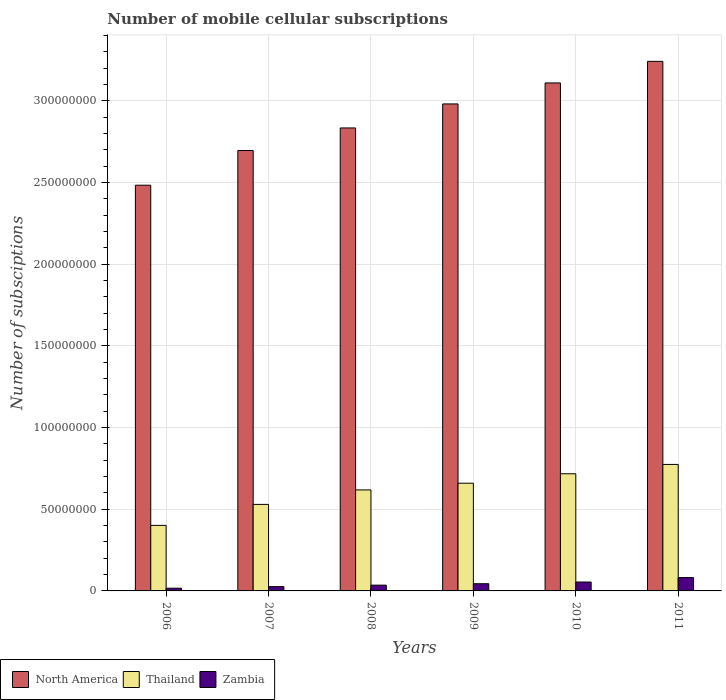How many different coloured bars are there?
Your response must be concise. 3. Are the number of bars per tick equal to the number of legend labels?
Your response must be concise. Yes. What is the number of mobile cellular subscriptions in North America in 2011?
Your answer should be very brief. 3.24e+08. Across all years, what is the maximum number of mobile cellular subscriptions in North America?
Ensure brevity in your answer.  3.24e+08. Across all years, what is the minimum number of mobile cellular subscriptions in Zambia?
Keep it short and to the point. 1.66e+06. In which year was the number of mobile cellular subscriptions in Thailand maximum?
Offer a terse response. 2011. What is the total number of mobile cellular subscriptions in Zambia in the graph?
Provide a short and direct response. 2.59e+07. What is the difference between the number of mobile cellular subscriptions in Zambia in 2008 and that in 2011?
Your response must be concise. -4.63e+06. What is the difference between the number of mobile cellular subscriptions in Thailand in 2011 and the number of mobile cellular subscriptions in North America in 2009?
Provide a short and direct response. -2.21e+08. What is the average number of mobile cellular subscriptions in North America per year?
Keep it short and to the point. 2.89e+08. In the year 2007, what is the difference between the number of mobile cellular subscriptions in North America and number of mobile cellular subscriptions in Zambia?
Offer a terse response. 2.67e+08. In how many years, is the number of mobile cellular subscriptions in North America greater than 320000000?
Offer a very short reply. 1. What is the ratio of the number of mobile cellular subscriptions in North America in 2009 to that in 2011?
Your answer should be very brief. 0.92. What is the difference between the highest and the second highest number of mobile cellular subscriptions in Zambia?
Offer a very short reply. 2.72e+06. What is the difference between the highest and the lowest number of mobile cellular subscriptions in North America?
Keep it short and to the point. 7.58e+07. In how many years, is the number of mobile cellular subscriptions in Thailand greater than the average number of mobile cellular subscriptions in Thailand taken over all years?
Offer a terse response. 4. What does the 3rd bar from the left in 2008 represents?
Ensure brevity in your answer.  Zambia. What does the 3rd bar from the right in 2011 represents?
Provide a short and direct response. North America. How many bars are there?
Your response must be concise. 18. Are all the bars in the graph horizontal?
Give a very brief answer. No. Are the values on the major ticks of Y-axis written in scientific E-notation?
Give a very brief answer. No. Does the graph contain any zero values?
Provide a succinct answer. No. Does the graph contain grids?
Make the answer very short. Yes. How are the legend labels stacked?
Provide a short and direct response. Horizontal. What is the title of the graph?
Your response must be concise. Number of mobile cellular subscriptions. What is the label or title of the X-axis?
Ensure brevity in your answer.  Years. What is the label or title of the Y-axis?
Give a very brief answer. Number of subsciptions. What is the Number of subsciptions in North America in 2006?
Offer a terse response. 2.48e+08. What is the Number of subsciptions in Thailand in 2006?
Provide a short and direct response. 4.01e+07. What is the Number of subsciptions of Zambia in 2006?
Your answer should be very brief. 1.66e+06. What is the Number of subsciptions in North America in 2007?
Give a very brief answer. 2.70e+08. What is the Number of subsciptions in Thailand in 2007?
Offer a very short reply. 5.30e+07. What is the Number of subsciptions of Zambia in 2007?
Make the answer very short. 2.64e+06. What is the Number of subsciptions of North America in 2008?
Offer a very short reply. 2.83e+08. What is the Number of subsciptions of Thailand in 2008?
Ensure brevity in your answer.  6.18e+07. What is the Number of subsciptions in Zambia in 2008?
Keep it short and to the point. 3.54e+06. What is the Number of subsciptions of North America in 2009?
Offer a very short reply. 2.98e+08. What is the Number of subsciptions in Thailand in 2009?
Provide a short and direct response. 6.60e+07. What is the Number of subsciptions of Zambia in 2009?
Offer a terse response. 4.41e+06. What is the Number of subsciptions in North America in 2010?
Give a very brief answer. 3.11e+08. What is the Number of subsciptions in Thailand in 2010?
Offer a very short reply. 7.17e+07. What is the Number of subsciptions in Zambia in 2010?
Ensure brevity in your answer.  5.45e+06. What is the Number of subsciptions of North America in 2011?
Your response must be concise. 3.24e+08. What is the Number of subsciptions in Thailand in 2011?
Offer a very short reply. 7.74e+07. What is the Number of subsciptions in Zambia in 2011?
Provide a succinct answer. 8.16e+06. Across all years, what is the maximum Number of subsciptions of North America?
Give a very brief answer. 3.24e+08. Across all years, what is the maximum Number of subsciptions in Thailand?
Your answer should be very brief. 7.74e+07. Across all years, what is the maximum Number of subsciptions in Zambia?
Keep it short and to the point. 8.16e+06. Across all years, what is the minimum Number of subsciptions in North America?
Your response must be concise. 2.48e+08. Across all years, what is the minimum Number of subsciptions in Thailand?
Your answer should be compact. 4.01e+07. Across all years, what is the minimum Number of subsciptions of Zambia?
Provide a succinct answer. 1.66e+06. What is the total Number of subsciptions in North America in the graph?
Make the answer very short. 1.73e+09. What is the total Number of subsciptions in Thailand in the graph?
Your response must be concise. 3.70e+08. What is the total Number of subsciptions in Zambia in the graph?
Provide a short and direct response. 2.59e+07. What is the difference between the Number of subsciptions of North America in 2006 and that in 2007?
Provide a succinct answer. -2.12e+07. What is the difference between the Number of subsciptions in Thailand in 2006 and that in 2007?
Ensure brevity in your answer.  -1.28e+07. What is the difference between the Number of subsciptions in Zambia in 2006 and that in 2007?
Provide a short and direct response. -9.76e+05. What is the difference between the Number of subsciptions of North America in 2006 and that in 2008?
Offer a terse response. -3.51e+07. What is the difference between the Number of subsciptions of Thailand in 2006 and that in 2008?
Your answer should be very brief. -2.17e+07. What is the difference between the Number of subsciptions in Zambia in 2006 and that in 2008?
Provide a succinct answer. -1.88e+06. What is the difference between the Number of subsciptions in North America in 2006 and that in 2009?
Make the answer very short. -4.98e+07. What is the difference between the Number of subsciptions of Thailand in 2006 and that in 2009?
Give a very brief answer. -2.58e+07. What is the difference between the Number of subsciptions in Zambia in 2006 and that in 2009?
Your answer should be compact. -2.74e+06. What is the difference between the Number of subsciptions in North America in 2006 and that in 2010?
Keep it short and to the point. -6.26e+07. What is the difference between the Number of subsciptions of Thailand in 2006 and that in 2010?
Give a very brief answer. -3.16e+07. What is the difference between the Number of subsciptions in Zambia in 2006 and that in 2010?
Your response must be concise. -3.78e+06. What is the difference between the Number of subsciptions in North America in 2006 and that in 2011?
Provide a short and direct response. -7.58e+07. What is the difference between the Number of subsciptions in Thailand in 2006 and that in 2011?
Your answer should be very brief. -3.73e+07. What is the difference between the Number of subsciptions of Zambia in 2006 and that in 2011?
Provide a succinct answer. -6.50e+06. What is the difference between the Number of subsciptions in North America in 2007 and that in 2008?
Your answer should be compact. -1.38e+07. What is the difference between the Number of subsciptions of Thailand in 2007 and that in 2008?
Offer a very short reply. -8.86e+06. What is the difference between the Number of subsciptions in Zambia in 2007 and that in 2008?
Make the answer very short. -9.00e+05. What is the difference between the Number of subsciptions in North America in 2007 and that in 2009?
Offer a very short reply. -2.85e+07. What is the difference between the Number of subsciptions of Thailand in 2007 and that in 2009?
Provide a succinct answer. -1.30e+07. What is the difference between the Number of subsciptions in Zambia in 2007 and that in 2009?
Provide a short and direct response. -1.77e+06. What is the difference between the Number of subsciptions in North America in 2007 and that in 2010?
Your response must be concise. -4.14e+07. What is the difference between the Number of subsciptions in Thailand in 2007 and that in 2010?
Give a very brief answer. -1.88e+07. What is the difference between the Number of subsciptions of Zambia in 2007 and that in 2010?
Provide a succinct answer. -2.81e+06. What is the difference between the Number of subsciptions in North America in 2007 and that in 2011?
Your answer should be very brief. -5.46e+07. What is the difference between the Number of subsciptions in Thailand in 2007 and that in 2011?
Keep it short and to the point. -2.45e+07. What is the difference between the Number of subsciptions of Zambia in 2007 and that in 2011?
Offer a very short reply. -5.53e+06. What is the difference between the Number of subsciptions in North America in 2008 and that in 2009?
Ensure brevity in your answer.  -1.47e+07. What is the difference between the Number of subsciptions of Thailand in 2008 and that in 2009?
Give a very brief answer. -4.12e+06. What is the difference between the Number of subsciptions in Zambia in 2008 and that in 2009?
Your answer should be very brief. -8.68e+05. What is the difference between the Number of subsciptions in North America in 2008 and that in 2010?
Keep it short and to the point. -2.76e+07. What is the difference between the Number of subsciptions in Thailand in 2008 and that in 2010?
Ensure brevity in your answer.  -9.89e+06. What is the difference between the Number of subsciptions in Zambia in 2008 and that in 2010?
Your response must be concise. -1.91e+06. What is the difference between the Number of subsciptions in North America in 2008 and that in 2011?
Offer a very short reply. -4.08e+07. What is the difference between the Number of subsciptions in Thailand in 2008 and that in 2011?
Give a very brief answer. -1.56e+07. What is the difference between the Number of subsciptions of Zambia in 2008 and that in 2011?
Your response must be concise. -4.63e+06. What is the difference between the Number of subsciptions of North America in 2009 and that in 2010?
Make the answer very short. -1.29e+07. What is the difference between the Number of subsciptions in Thailand in 2009 and that in 2010?
Provide a short and direct response. -5.77e+06. What is the difference between the Number of subsciptions of Zambia in 2009 and that in 2010?
Your answer should be very brief. -1.04e+06. What is the difference between the Number of subsciptions of North America in 2009 and that in 2011?
Make the answer very short. -2.61e+07. What is the difference between the Number of subsciptions of Thailand in 2009 and that in 2011?
Give a very brief answer. -1.15e+07. What is the difference between the Number of subsciptions in Zambia in 2009 and that in 2011?
Provide a succinct answer. -3.76e+06. What is the difference between the Number of subsciptions of North America in 2010 and that in 2011?
Your answer should be compact. -1.32e+07. What is the difference between the Number of subsciptions of Thailand in 2010 and that in 2011?
Your answer should be compact. -5.72e+06. What is the difference between the Number of subsciptions in Zambia in 2010 and that in 2011?
Your response must be concise. -2.72e+06. What is the difference between the Number of subsciptions in North America in 2006 and the Number of subsciptions in Thailand in 2007?
Keep it short and to the point. 1.95e+08. What is the difference between the Number of subsciptions of North America in 2006 and the Number of subsciptions of Zambia in 2007?
Keep it short and to the point. 2.46e+08. What is the difference between the Number of subsciptions of Thailand in 2006 and the Number of subsciptions of Zambia in 2007?
Your answer should be very brief. 3.75e+07. What is the difference between the Number of subsciptions of North America in 2006 and the Number of subsciptions of Thailand in 2008?
Your answer should be compact. 1.87e+08. What is the difference between the Number of subsciptions of North America in 2006 and the Number of subsciptions of Zambia in 2008?
Give a very brief answer. 2.45e+08. What is the difference between the Number of subsciptions in Thailand in 2006 and the Number of subsciptions in Zambia in 2008?
Provide a succinct answer. 3.66e+07. What is the difference between the Number of subsciptions in North America in 2006 and the Number of subsciptions in Thailand in 2009?
Your answer should be compact. 1.82e+08. What is the difference between the Number of subsciptions in North America in 2006 and the Number of subsciptions in Zambia in 2009?
Provide a short and direct response. 2.44e+08. What is the difference between the Number of subsciptions in Thailand in 2006 and the Number of subsciptions in Zambia in 2009?
Offer a very short reply. 3.57e+07. What is the difference between the Number of subsciptions of North America in 2006 and the Number of subsciptions of Thailand in 2010?
Offer a terse response. 1.77e+08. What is the difference between the Number of subsciptions of North America in 2006 and the Number of subsciptions of Zambia in 2010?
Offer a terse response. 2.43e+08. What is the difference between the Number of subsciptions of Thailand in 2006 and the Number of subsciptions of Zambia in 2010?
Make the answer very short. 3.47e+07. What is the difference between the Number of subsciptions in North America in 2006 and the Number of subsciptions in Thailand in 2011?
Your answer should be compact. 1.71e+08. What is the difference between the Number of subsciptions of North America in 2006 and the Number of subsciptions of Zambia in 2011?
Keep it short and to the point. 2.40e+08. What is the difference between the Number of subsciptions in Thailand in 2006 and the Number of subsciptions in Zambia in 2011?
Make the answer very short. 3.20e+07. What is the difference between the Number of subsciptions in North America in 2007 and the Number of subsciptions in Thailand in 2008?
Offer a very short reply. 2.08e+08. What is the difference between the Number of subsciptions of North America in 2007 and the Number of subsciptions of Zambia in 2008?
Give a very brief answer. 2.66e+08. What is the difference between the Number of subsciptions in Thailand in 2007 and the Number of subsciptions in Zambia in 2008?
Offer a very short reply. 4.94e+07. What is the difference between the Number of subsciptions in North America in 2007 and the Number of subsciptions in Thailand in 2009?
Your answer should be compact. 2.04e+08. What is the difference between the Number of subsciptions in North America in 2007 and the Number of subsciptions in Zambia in 2009?
Provide a short and direct response. 2.65e+08. What is the difference between the Number of subsciptions of Thailand in 2007 and the Number of subsciptions of Zambia in 2009?
Your response must be concise. 4.86e+07. What is the difference between the Number of subsciptions of North America in 2007 and the Number of subsciptions of Thailand in 2010?
Your response must be concise. 1.98e+08. What is the difference between the Number of subsciptions in North America in 2007 and the Number of subsciptions in Zambia in 2010?
Offer a very short reply. 2.64e+08. What is the difference between the Number of subsciptions of Thailand in 2007 and the Number of subsciptions of Zambia in 2010?
Make the answer very short. 4.75e+07. What is the difference between the Number of subsciptions of North America in 2007 and the Number of subsciptions of Thailand in 2011?
Make the answer very short. 1.92e+08. What is the difference between the Number of subsciptions in North America in 2007 and the Number of subsciptions in Zambia in 2011?
Offer a terse response. 2.61e+08. What is the difference between the Number of subsciptions of Thailand in 2007 and the Number of subsciptions of Zambia in 2011?
Your response must be concise. 4.48e+07. What is the difference between the Number of subsciptions of North America in 2008 and the Number of subsciptions of Thailand in 2009?
Offer a terse response. 2.18e+08. What is the difference between the Number of subsciptions of North America in 2008 and the Number of subsciptions of Zambia in 2009?
Your response must be concise. 2.79e+08. What is the difference between the Number of subsciptions of Thailand in 2008 and the Number of subsciptions of Zambia in 2009?
Give a very brief answer. 5.74e+07. What is the difference between the Number of subsciptions in North America in 2008 and the Number of subsciptions in Thailand in 2010?
Make the answer very short. 2.12e+08. What is the difference between the Number of subsciptions of North America in 2008 and the Number of subsciptions of Zambia in 2010?
Provide a short and direct response. 2.78e+08. What is the difference between the Number of subsciptions in Thailand in 2008 and the Number of subsciptions in Zambia in 2010?
Ensure brevity in your answer.  5.64e+07. What is the difference between the Number of subsciptions in North America in 2008 and the Number of subsciptions in Thailand in 2011?
Make the answer very short. 2.06e+08. What is the difference between the Number of subsciptions in North America in 2008 and the Number of subsciptions in Zambia in 2011?
Your answer should be compact. 2.75e+08. What is the difference between the Number of subsciptions of Thailand in 2008 and the Number of subsciptions of Zambia in 2011?
Provide a short and direct response. 5.37e+07. What is the difference between the Number of subsciptions of North America in 2009 and the Number of subsciptions of Thailand in 2010?
Give a very brief answer. 2.26e+08. What is the difference between the Number of subsciptions of North America in 2009 and the Number of subsciptions of Zambia in 2010?
Ensure brevity in your answer.  2.93e+08. What is the difference between the Number of subsciptions of Thailand in 2009 and the Number of subsciptions of Zambia in 2010?
Give a very brief answer. 6.05e+07. What is the difference between the Number of subsciptions of North America in 2009 and the Number of subsciptions of Thailand in 2011?
Give a very brief answer. 2.21e+08. What is the difference between the Number of subsciptions in North America in 2009 and the Number of subsciptions in Zambia in 2011?
Keep it short and to the point. 2.90e+08. What is the difference between the Number of subsciptions of Thailand in 2009 and the Number of subsciptions of Zambia in 2011?
Offer a very short reply. 5.78e+07. What is the difference between the Number of subsciptions of North America in 2010 and the Number of subsciptions of Thailand in 2011?
Offer a very short reply. 2.34e+08. What is the difference between the Number of subsciptions of North America in 2010 and the Number of subsciptions of Zambia in 2011?
Your answer should be very brief. 3.03e+08. What is the difference between the Number of subsciptions of Thailand in 2010 and the Number of subsciptions of Zambia in 2011?
Keep it short and to the point. 6.36e+07. What is the average Number of subsciptions of North America per year?
Offer a terse response. 2.89e+08. What is the average Number of subsciptions in Thailand per year?
Your response must be concise. 6.17e+07. What is the average Number of subsciptions in Zambia per year?
Your answer should be compact. 4.31e+06. In the year 2006, what is the difference between the Number of subsciptions in North America and Number of subsciptions in Thailand?
Offer a very short reply. 2.08e+08. In the year 2006, what is the difference between the Number of subsciptions of North America and Number of subsciptions of Zambia?
Keep it short and to the point. 2.47e+08. In the year 2006, what is the difference between the Number of subsciptions of Thailand and Number of subsciptions of Zambia?
Your answer should be compact. 3.85e+07. In the year 2007, what is the difference between the Number of subsciptions of North America and Number of subsciptions of Thailand?
Your response must be concise. 2.17e+08. In the year 2007, what is the difference between the Number of subsciptions of North America and Number of subsciptions of Zambia?
Provide a short and direct response. 2.67e+08. In the year 2007, what is the difference between the Number of subsciptions in Thailand and Number of subsciptions in Zambia?
Give a very brief answer. 5.03e+07. In the year 2008, what is the difference between the Number of subsciptions in North America and Number of subsciptions in Thailand?
Offer a terse response. 2.22e+08. In the year 2008, what is the difference between the Number of subsciptions in North America and Number of subsciptions in Zambia?
Provide a short and direct response. 2.80e+08. In the year 2008, what is the difference between the Number of subsciptions in Thailand and Number of subsciptions in Zambia?
Provide a succinct answer. 5.83e+07. In the year 2009, what is the difference between the Number of subsciptions of North America and Number of subsciptions of Thailand?
Offer a very short reply. 2.32e+08. In the year 2009, what is the difference between the Number of subsciptions in North America and Number of subsciptions in Zambia?
Your answer should be very brief. 2.94e+08. In the year 2009, what is the difference between the Number of subsciptions of Thailand and Number of subsciptions of Zambia?
Your answer should be very brief. 6.15e+07. In the year 2010, what is the difference between the Number of subsciptions in North America and Number of subsciptions in Thailand?
Give a very brief answer. 2.39e+08. In the year 2010, what is the difference between the Number of subsciptions of North America and Number of subsciptions of Zambia?
Offer a terse response. 3.06e+08. In the year 2010, what is the difference between the Number of subsciptions of Thailand and Number of subsciptions of Zambia?
Your response must be concise. 6.63e+07. In the year 2011, what is the difference between the Number of subsciptions in North America and Number of subsciptions in Thailand?
Offer a very short reply. 2.47e+08. In the year 2011, what is the difference between the Number of subsciptions of North America and Number of subsciptions of Zambia?
Offer a terse response. 3.16e+08. In the year 2011, what is the difference between the Number of subsciptions of Thailand and Number of subsciptions of Zambia?
Make the answer very short. 6.93e+07. What is the ratio of the Number of subsciptions of North America in 2006 to that in 2007?
Provide a short and direct response. 0.92. What is the ratio of the Number of subsciptions in Thailand in 2006 to that in 2007?
Your response must be concise. 0.76. What is the ratio of the Number of subsciptions of Zambia in 2006 to that in 2007?
Provide a succinct answer. 0.63. What is the ratio of the Number of subsciptions in North America in 2006 to that in 2008?
Your answer should be compact. 0.88. What is the ratio of the Number of subsciptions in Thailand in 2006 to that in 2008?
Ensure brevity in your answer.  0.65. What is the ratio of the Number of subsciptions of Zambia in 2006 to that in 2008?
Make the answer very short. 0.47. What is the ratio of the Number of subsciptions of North America in 2006 to that in 2009?
Keep it short and to the point. 0.83. What is the ratio of the Number of subsciptions in Thailand in 2006 to that in 2009?
Ensure brevity in your answer.  0.61. What is the ratio of the Number of subsciptions in Zambia in 2006 to that in 2009?
Ensure brevity in your answer.  0.38. What is the ratio of the Number of subsciptions in North America in 2006 to that in 2010?
Your response must be concise. 0.8. What is the ratio of the Number of subsciptions of Thailand in 2006 to that in 2010?
Give a very brief answer. 0.56. What is the ratio of the Number of subsciptions of Zambia in 2006 to that in 2010?
Keep it short and to the point. 0.31. What is the ratio of the Number of subsciptions of North America in 2006 to that in 2011?
Ensure brevity in your answer.  0.77. What is the ratio of the Number of subsciptions in Thailand in 2006 to that in 2011?
Provide a short and direct response. 0.52. What is the ratio of the Number of subsciptions of Zambia in 2006 to that in 2011?
Offer a very short reply. 0.2. What is the ratio of the Number of subsciptions of North America in 2007 to that in 2008?
Provide a short and direct response. 0.95. What is the ratio of the Number of subsciptions of Thailand in 2007 to that in 2008?
Your answer should be compact. 0.86. What is the ratio of the Number of subsciptions of Zambia in 2007 to that in 2008?
Offer a terse response. 0.75. What is the ratio of the Number of subsciptions in North America in 2007 to that in 2009?
Your response must be concise. 0.9. What is the ratio of the Number of subsciptions in Thailand in 2007 to that in 2009?
Make the answer very short. 0.8. What is the ratio of the Number of subsciptions of Zambia in 2007 to that in 2009?
Keep it short and to the point. 0.6. What is the ratio of the Number of subsciptions of North America in 2007 to that in 2010?
Give a very brief answer. 0.87. What is the ratio of the Number of subsciptions in Thailand in 2007 to that in 2010?
Provide a succinct answer. 0.74. What is the ratio of the Number of subsciptions in Zambia in 2007 to that in 2010?
Give a very brief answer. 0.48. What is the ratio of the Number of subsciptions in North America in 2007 to that in 2011?
Ensure brevity in your answer.  0.83. What is the ratio of the Number of subsciptions of Thailand in 2007 to that in 2011?
Your response must be concise. 0.68. What is the ratio of the Number of subsciptions in Zambia in 2007 to that in 2011?
Provide a short and direct response. 0.32. What is the ratio of the Number of subsciptions of North America in 2008 to that in 2009?
Provide a short and direct response. 0.95. What is the ratio of the Number of subsciptions in Thailand in 2008 to that in 2009?
Make the answer very short. 0.94. What is the ratio of the Number of subsciptions of Zambia in 2008 to that in 2009?
Give a very brief answer. 0.8. What is the ratio of the Number of subsciptions in North America in 2008 to that in 2010?
Your answer should be very brief. 0.91. What is the ratio of the Number of subsciptions of Thailand in 2008 to that in 2010?
Make the answer very short. 0.86. What is the ratio of the Number of subsciptions of Zambia in 2008 to that in 2010?
Ensure brevity in your answer.  0.65. What is the ratio of the Number of subsciptions of North America in 2008 to that in 2011?
Ensure brevity in your answer.  0.87. What is the ratio of the Number of subsciptions in Thailand in 2008 to that in 2011?
Keep it short and to the point. 0.8. What is the ratio of the Number of subsciptions of Zambia in 2008 to that in 2011?
Ensure brevity in your answer.  0.43. What is the ratio of the Number of subsciptions in North America in 2009 to that in 2010?
Provide a short and direct response. 0.96. What is the ratio of the Number of subsciptions in Thailand in 2009 to that in 2010?
Your response must be concise. 0.92. What is the ratio of the Number of subsciptions in Zambia in 2009 to that in 2010?
Ensure brevity in your answer.  0.81. What is the ratio of the Number of subsciptions of North America in 2009 to that in 2011?
Your answer should be very brief. 0.92. What is the ratio of the Number of subsciptions of Thailand in 2009 to that in 2011?
Your response must be concise. 0.85. What is the ratio of the Number of subsciptions of Zambia in 2009 to that in 2011?
Keep it short and to the point. 0.54. What is the ratio of the Number of subsciptions of North America in 2010 to that in 2011?
Ensure brevity in your answer.  0.96. What is the ratio of the Number of subsciptions in Thailand in 2010 to that in 2011?
Offer a very short reply. 0.93. What is the ratio of the Number of subsciptions of Zambia in 2010 to that in 2011?
Offer a terse response. 0.67. What is the difference between the highest and the second highest Number of subsciptions of North America?
Ensure brevity in your answer.  1.32e+07. What is the difference between the highest and the second highest Number of subsciptions in Thailand?
Make the answer very short. 5.72e+06. What is the difference between the highest and the second highest Number of subsciptions of Zambia?
Offer a terse response. 2.72e+06. What is the difference between the highest and the lowest Number of subsciptions of North America?
Offer a terse response. 7.58e+07. What is the difference between the highest and the lowest Number of subsciptions of Thailand?
Give a very brief answer. 3.73e+07. What is the difference between the highest and the lowest Number of subsciptions in Zambia?
Keep it short and to the point. 6.50e+06. 